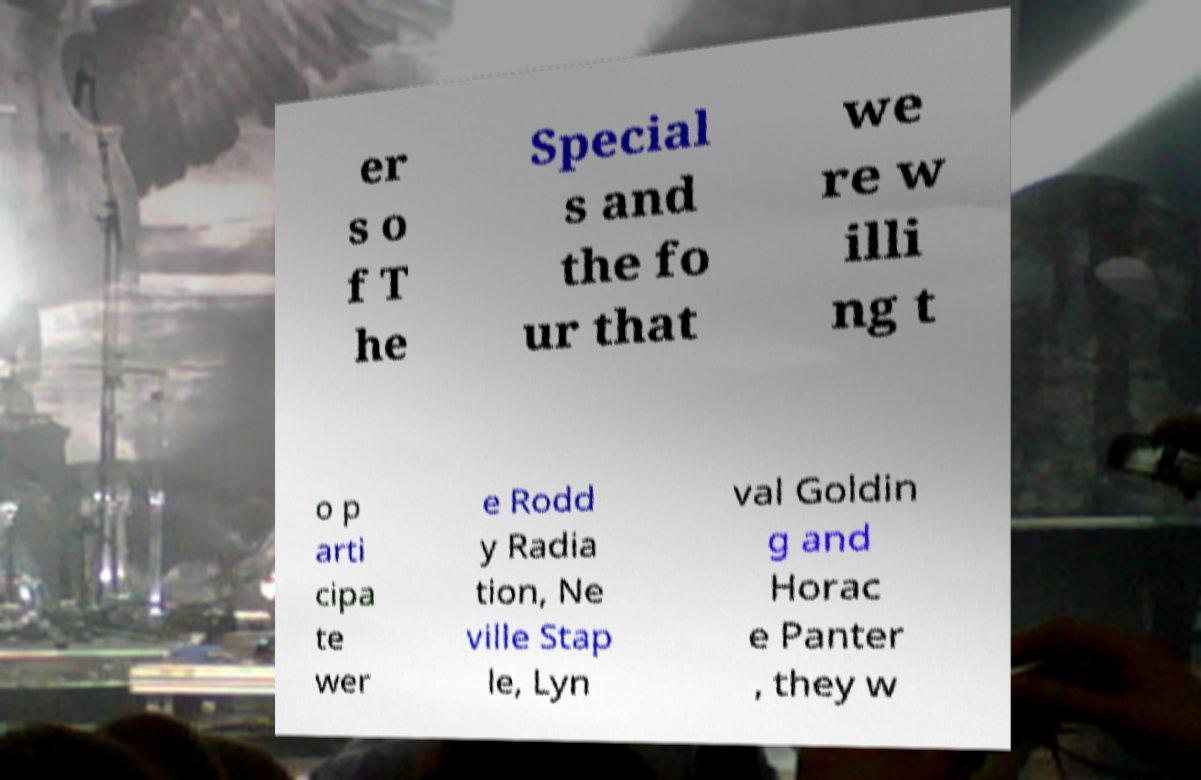What messages or text are displayed in this image? I need them in a readable, typed format. er s o f T he Special s and the fo ur that we re w illi ng t o p arti cipa te wer e Rodd y Radia tion, Ne ville Stap le, Lyn val Goldin g and Horac e Panter , they w 